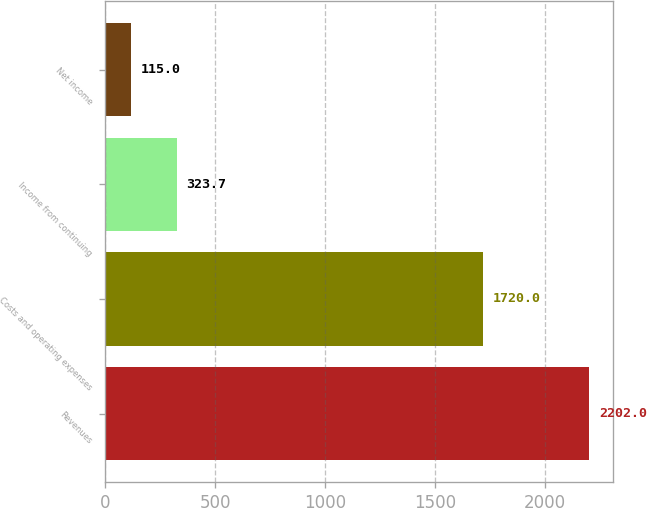Convert chart to OTSL. <chart><loc_0><loc_0><loc_500><loc_500><bar_chart><fcel>Revenues<fcel>Costs and operating expenses<fcel>Income from continuing<fcel>Net income<nl><fcel>2202<fcel>1720<fcel>323.7<fcel>115<nl></chart> 